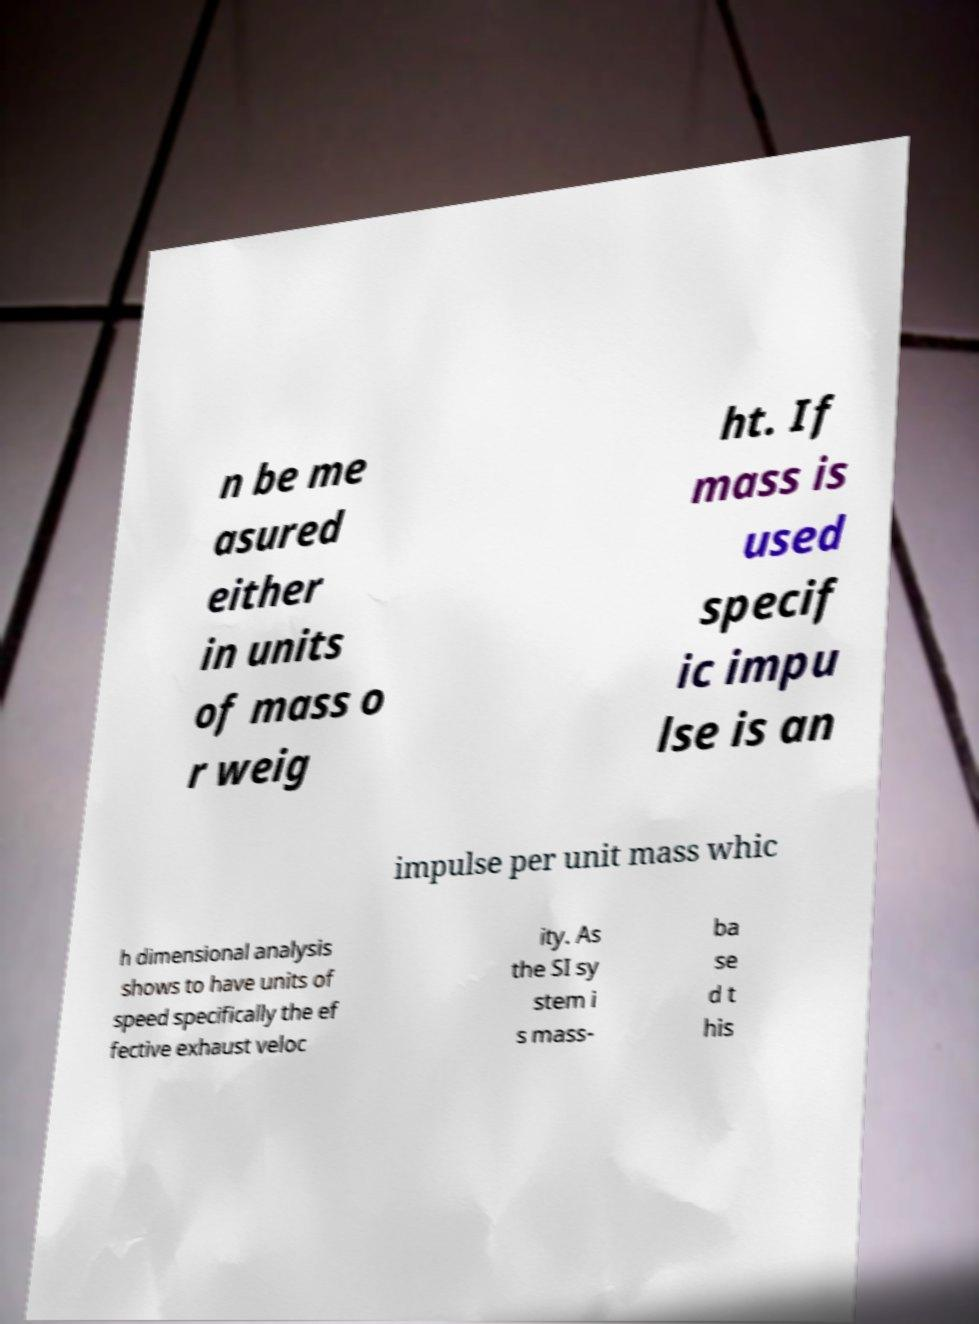Could you extract and type out the text from this image? n be me asured either in units of mass o r weig ht. If mass is used specif ic impu lse is an impulse per unit mass whic h dimensional analysis shows to have units of speed specifically the ef fective exhaust veloc ity. As the SI sy stem i s mass- ba se d t his 